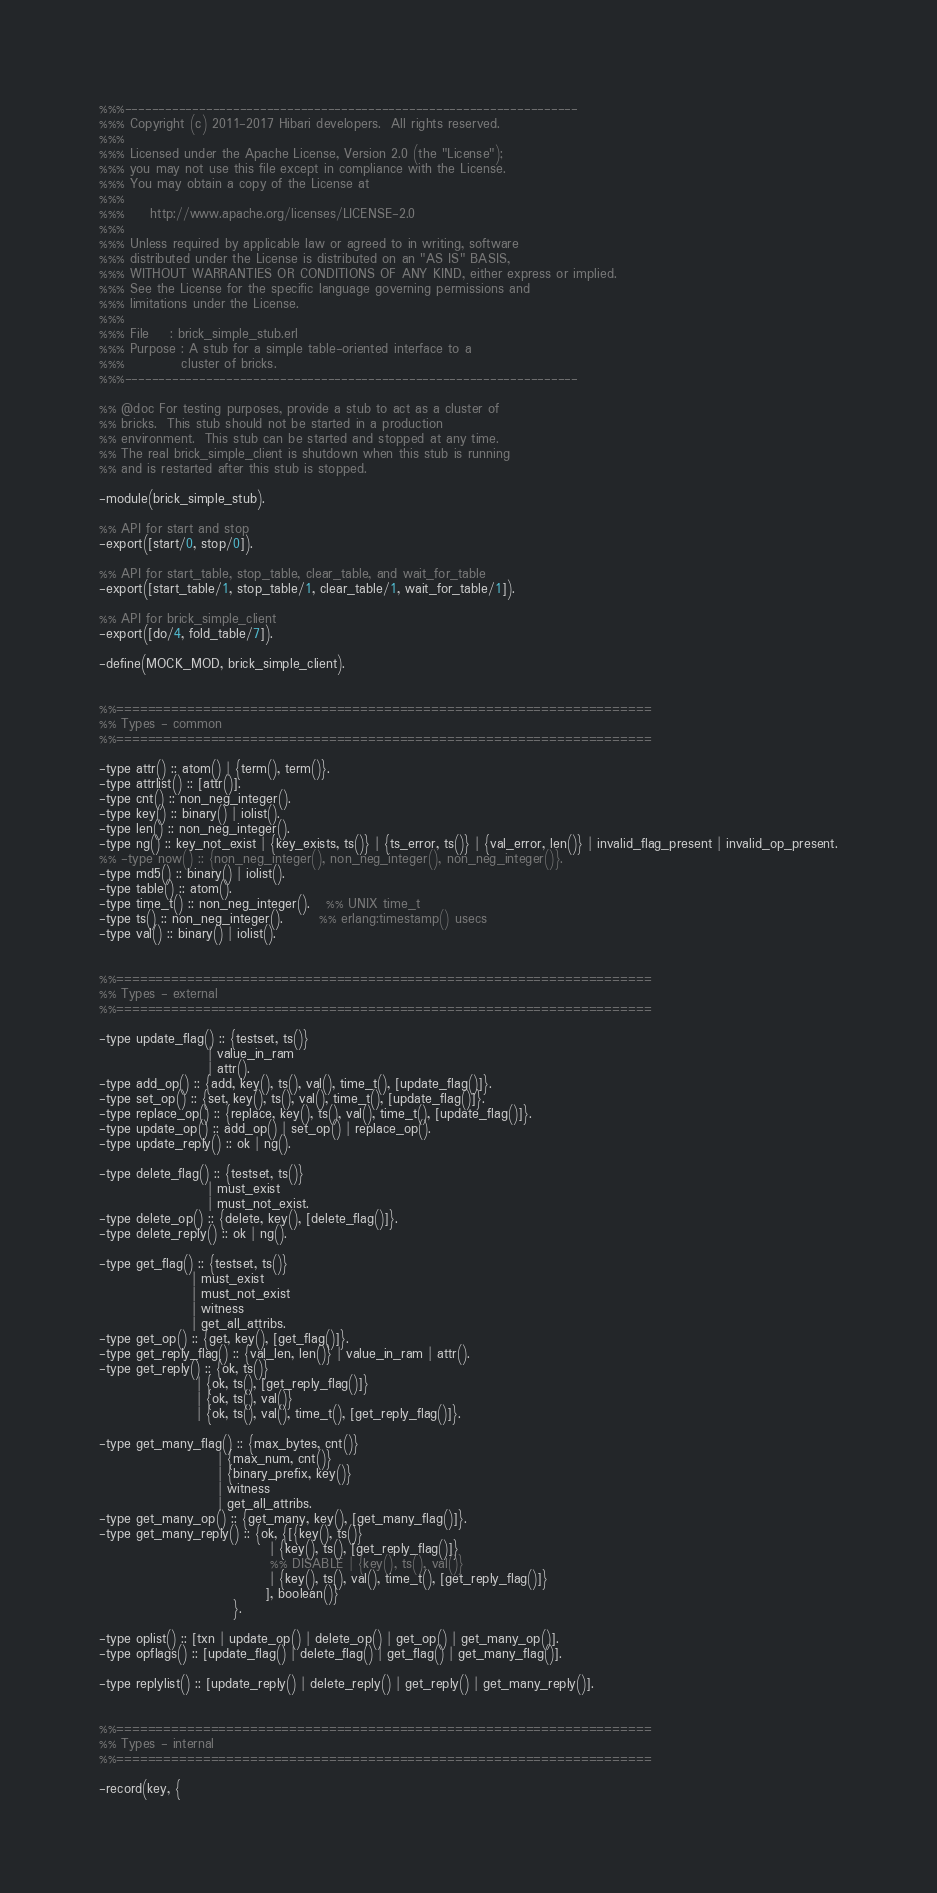Convert code to text. <code><loc_0><loc_0><loc_500><loc_500><_Erlang_>%%%-------------------------------------------------------------------
%%% Copyright (c) 2011-2017 Hibari developers.  All rights reserved.
%%%
%%% Licensed under the Apache License, Version 2.0 (the "License");
%%% you may not use this file except in compliance with the License.
%%% You may obtain a copy of the License at
%%%
%%%     http://www.apache.org/licenses/LICENSE-2.0
%%%
%%% Unless required by applicable law or agreed to in writing, software
%%% distributed under the License is distributed on an "AS IS" BASIS,
%%% WITHOUT WARRANTIES OR CONDITIONS OF ANY KIND, either express or implied.
%%% See the License for the specific language governing permissions and
%%% limitations under the License.
%%%
%%% File    : brick_simple_stub.erl
%%% Purpose : A stub for a simple table-oriented interface to a
%%%           cluster of bricks.
%%%-------------------------------------------------------------------

%% @doc For testing purposes, provide a stub to act as a cluster of
%% bricks.  This stub should not be started in a production
%% environment.  This stub can be started and stopped at any time.
%% The real brick_simple_client is shutdown when this stub is running
%% and is restarted after this stub is stopped.

-module(brick_simple_stub).

%% API for start and stop
-export([start/0, stop/0]).

%% API for start_table, stop_table, clear_table, and wait_for_table
-export([start_table/1, stop_table/1, clear_table/1, wait_for_table/1]).

%% API for brick_simple_client
-export([do/4, fold_table/7]).

-define(MOCK_MOD, brick_simple_client).


%%====================================================================
%% Types - common
%%====================================================================

-type attr() :: atom() | {term(), term()}.
-type attrlist() :: [attr()].
-type cnt() :: non_neg_integer().
-type key() :: binary() | iolist().
-type len() :: non_neg_integer().
-type ng() :: key_not_exist | {key_exists, ts()} | {ts_error, ts()} | {val_error, len()} | invalid_flag_present | invalid_op_present.
%% -type now() :: {non_neg_integer(), non_neg_integer(), non_neg_integer()}.
-type md5() :: binary() | iolist().
-type table() :: atom().
-type time_t() :: non_neg_integer().   %% UNIX time_t
-type ts() :: non_neg_integer().       %% erlang:timestamp() usecs
-type val() :: binary() | iolist().


%%====================================================================
%% Types - external
%%====================================================================

-type update_flag() :: {testset, ts()}
                     | value_in_ram
                     | attr().
-type add_op() :: {add, key(), ts(), val(), time_t(), [update_flag()]}.
-type set_op() :: {set, key(), ts(), val(), time_t(), [update_flag()]}.
-type replace_op() :: {replace, key(), ts(), val(), time_t(), [update_flag()]}.
-type update_op() :: add_op() | set_op() | replace_op().
-type update_reply() :: ok | ng().

-type delete_flag() :: {testset, ts()}
                     | must_exist
                     | must_not_exist.
-type delete_op() :: {delete, key(), [delete_flag()]}.
-type delete_reply() :: ok | ng().

-type get_flag() :: {testset, ts()}
                  | must_exist
                  | must_not_exist
                  | witness
                  | get_all_attribs.
-type get_op() :: {get, key(), [get_flag()]}.
-type get_reply_flag() :: {val_len, len()} | value_in_ram | attr().
-type get_reply() :: {ok, ts()}
                   | {ok, ts(), [get_reply_flag()]}
                   | {ok, ts(), val()}
                   | {ok, ts(), val(), time_t(), [get_reply_flag()]}.

-type get_many_flag() :: {max_bytes, cnt()}
                       | {max_num, cnt()}
                       | {binary_prefix, key()}
                       | witness
                       | get_all_attribs.
-type get_many_op() :: {get_many, key(), [get_many_flag()]}.
-type get_many_reply() :: {ok, {[{key(), ts()}
                                 | {key(), ts(), [get_reply_flag()]}
                                 %% DISABLE | {key(), ts(), val()}
                                 | {key(), ts(), val(), time_t(), [get_reply_flag()]}
                                ], boolean()}
                          }.

-type oplist() :: [txn | update_op() | delete_op() | get_op() | get_many_op()].
-type opflags() :: [update_flag() | delete_flag() | get_flag() | get_many_flag()].

-type replylist() :: [update_reply() | delete_reply() | get_reply() | get_many_reply()].


%%====================================================================
%% Types - internal
%%====================================================================

-record(key, {</code> 